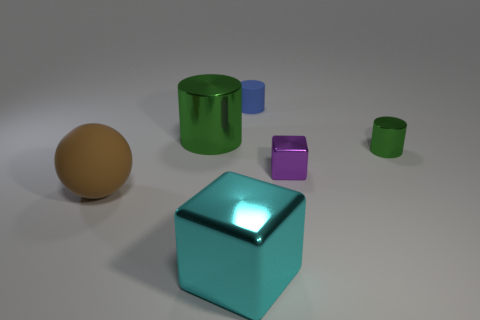Add 2 big cylinders. How many objects exist? 8 Subtract all spheres. How many objects are left? 5 Add 6 tiny green shiny cylinders. How many tiny green shiny cylinders exist? 7 Subtract 0 red cubes. How many objects are left? 6 Subtract all small brown matte cylinders. Subtract all large brown things. How many objects are left? 5 Add 1 matte things. How many matte things are left? 3 